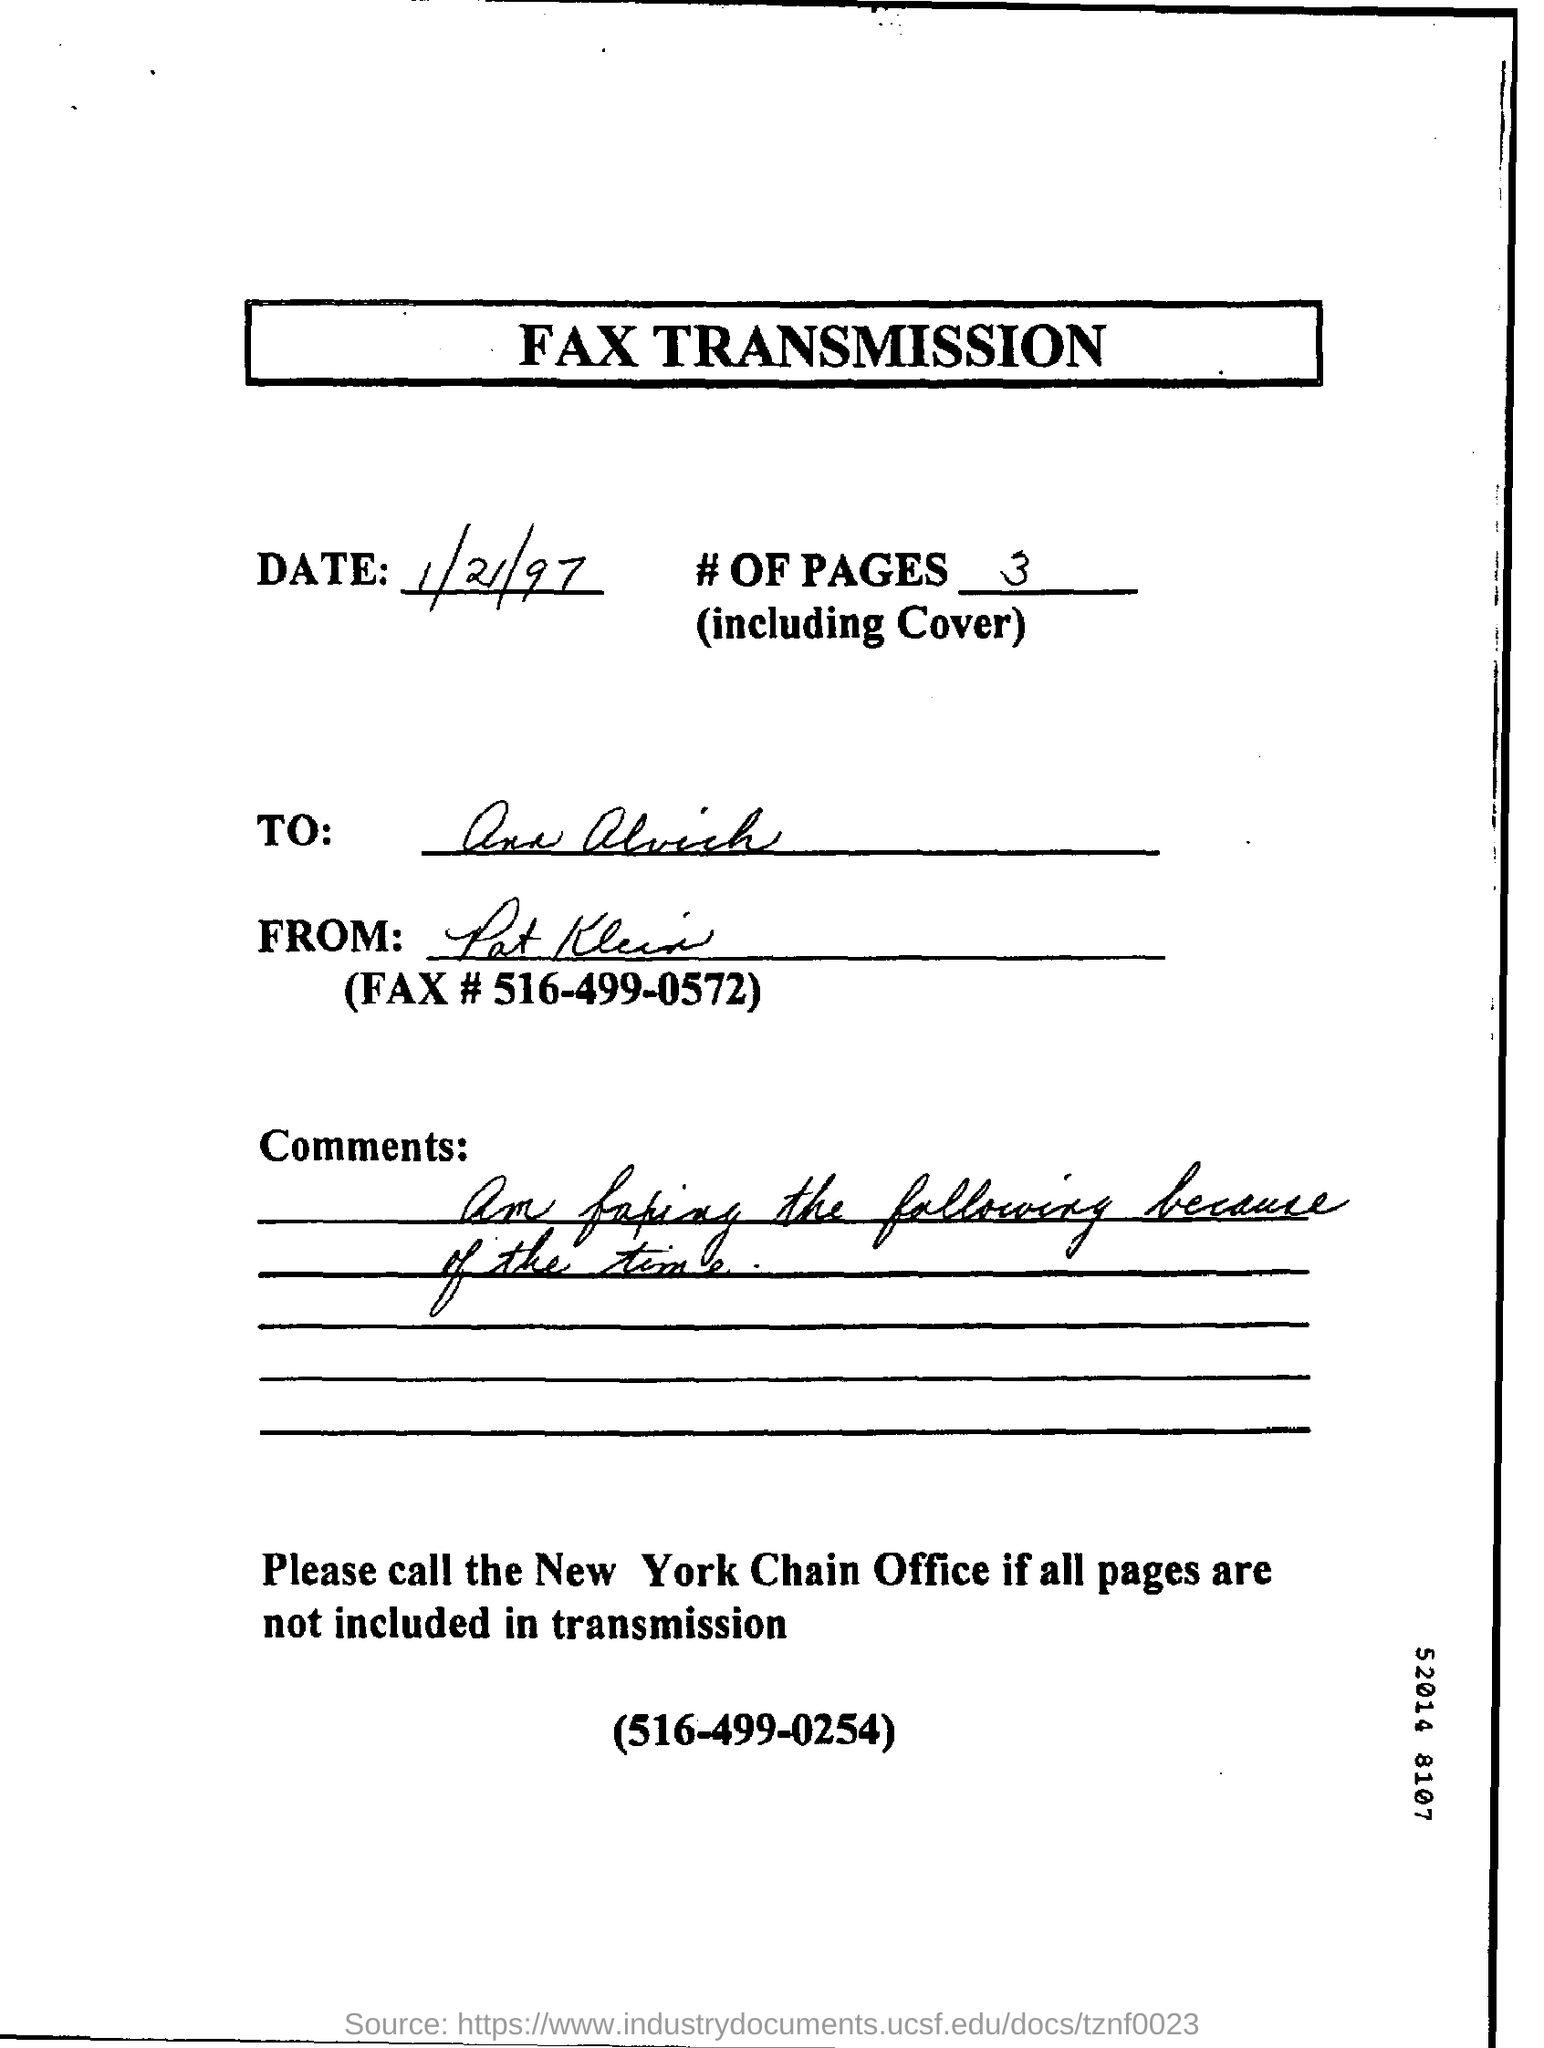Draw attention to some important aspects in this diagram. The date mentioned in the document is January 21, 1997. The contact number for the New York Chain Office is (516) 499-0254. This is the form for FAX TRANSMISSION. 